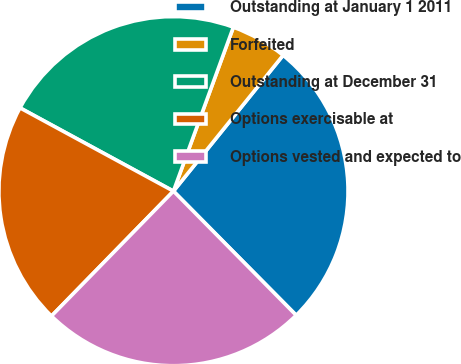Convert chart. <chart><loc_0><loc_0><loc_500><loc_500><pie_chart><fcel>Outstanding at January 1 2011<fcel>Forfeited<fcel>Outstanding at December 31<fcel>Options exercisable at<fcel>Options vested and expected to<nl><fcel>26.78%<fcel>5.23%<fcel>22.66%<fcel>20.6%<fcel>24.72%<nl></chart> 